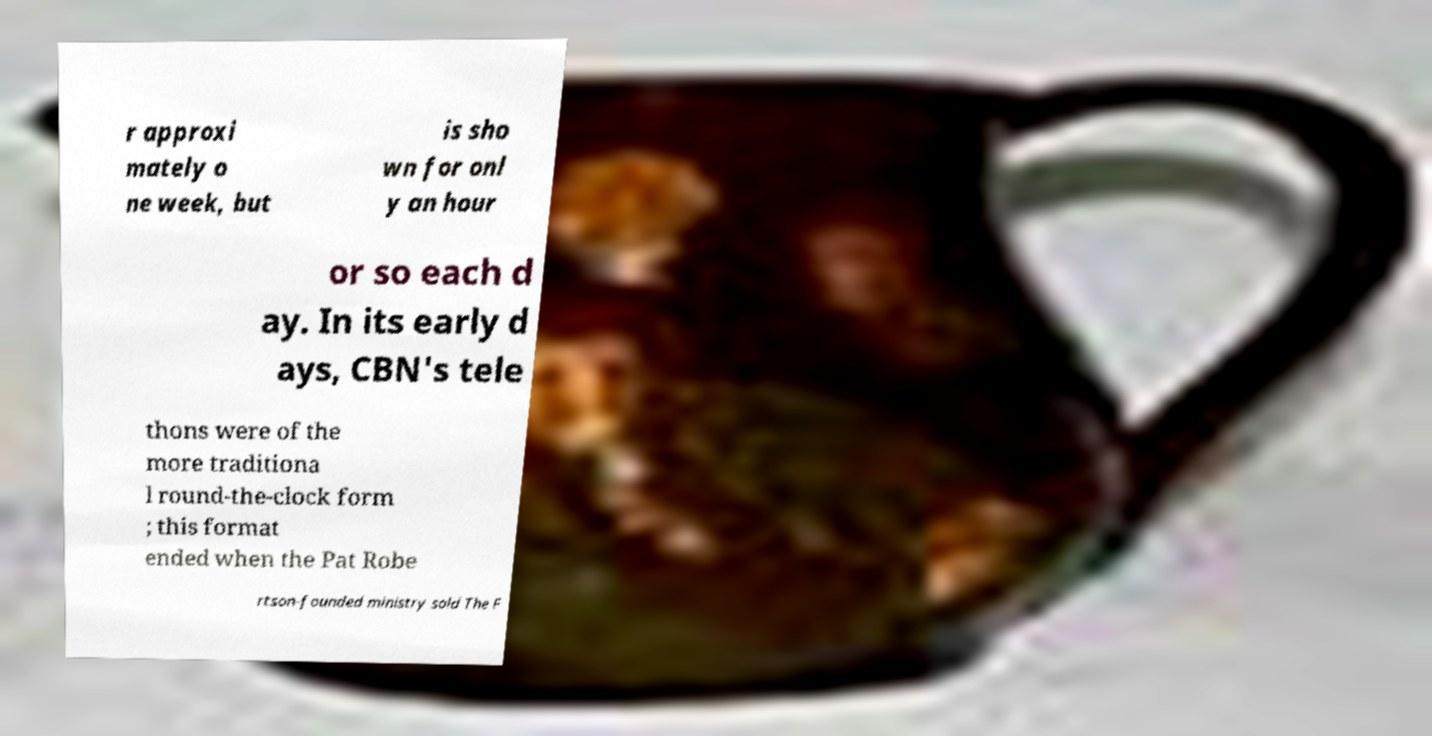What messages or text are displayed in this image? I need them in a readable, typed format. r approxi mately o ne week, but is sho wn for onl y an hour or so each d ay. In its early d ays, CBN's tele thons were of the more traditiona l round-the-clock form ; this format ended when the Pat Robe rtson-founded ministry sold The F 